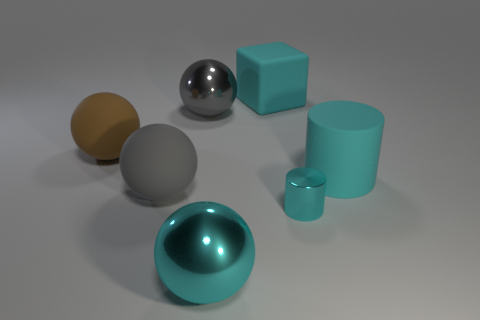There is a big sphere that is the same color as the shiny cylinder; what is it made of?
Offer a very short reply. Metal. What number of other things are there of the same color as the cube?
Keep it short and to the point. 3. Is there any other thing that is the same shape as the brown matte object?
Offer a terse response. Yes. Does the metal ball that is left of the cyan sphere have the same size as the tiny cylinder?
Ensure brevity in your answer.  No. What number of shiny things are either tiny cyan cylinders or brown balls?
Provide a succinct answer. 1. How big is the cyan thing that is left of the big cyan rubber cube?
Make the answer very short. Large. Is the number of large cylinders the same as the number of large shiny objects?
Provide a succinct answer. No. Is the shape of the big brown rubber thing the same as the gray matte object?
Make the answer very short. Yes. How many small things are blue metallic cylinders or rubber spheres?
Give a very brief answer. 0. Are there any gray balls on the left side of the big gray rubber sphere?
Give a very brief answer. No. 